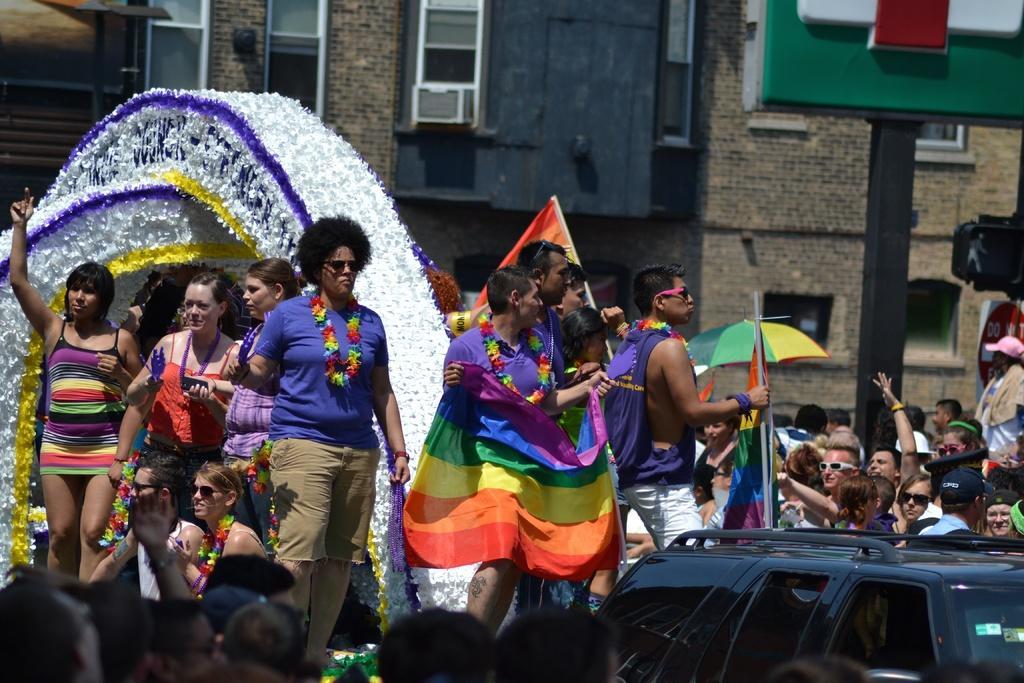In one or two sentences, can you explain what this image depicts? In this image, I can see groups of people standing and two people sitting. On the left side of the image, It is a structure with the decorative items. At the bottom right side of the image, I can see a vehicle. In the background, there is a building with windows, an umbrella and a pole. 